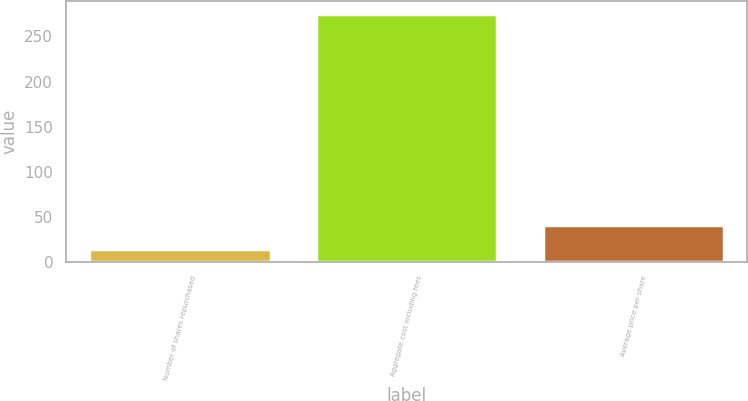Convert chart to OTSL. <chart><loc_0><loc_0><loc_500><loc_500><bar_chart><fcel>Number of shares repurchased<fcel>Aggregate cost including fees<fcel>Average price per share<nl><fcel>14.9<fcel>275.1<fcel>40.92<nl></chart> 